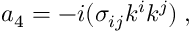<formula> <loc_0><loc_0><loc_500><loc_500>a _ { 4 } = - i ( \sigma _ { i j } k ^ { i } k ^ { j } ) \, ,</formula> 